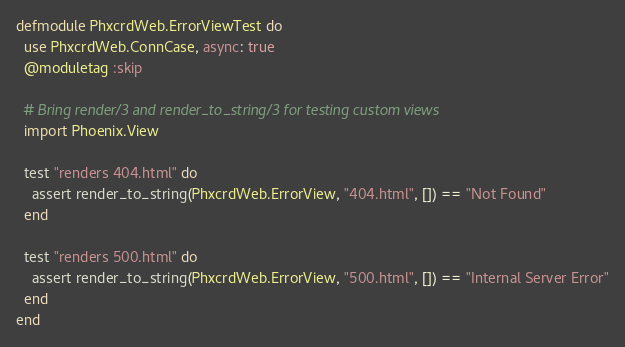Convert code to text. <code><loc_0><loc_0><loc_500><loc_500><_Elixir_>defmodule PhxcrdWeb.ErrorViewTest do
  use PhxcrdWeb.ConnCase, async: true
  @moduletag :skip

  # Bring render/3 and render_to_string/3 for testing custom views
  import Phoenix.View

  test "renders 404.html" do
    assert render_to_string(PhxcrdWeb.ErrorView, "404.html", []) == "Not Found"
  end

  test "renders 500.html" do
    assert render_to_string(PhxcrdWeb.ErrorView, "500.html", []) == "Internal Server Error"
  end
end
</code> 